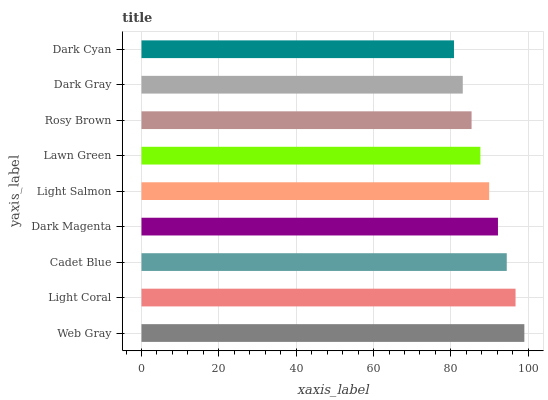Is Dark Cyan the minimum?
Answer yes or no. Yes. Is Web Gray the maximum?
Answer yes or no. Yes. Is Light Coral the minimum?
Answer yes or no. No. Is Light Coral the maximum?
Answer yes or no. No. Is Web Gray greater than Light Coral?
Answer yes or no. Yes. Is Light Coral less than Web Gray?
Answer yes or no. Yes. Is Light Coral greater than Web Gray?
Answer yes or no. No. Is Web Gray less than Light Coral?
Answer yes or no. No. Is Light Salmon the high median?
Answer yes or no. Yes. Is Light Salmon the low median?
Answer yes or no. Yes. Is Light Coral the high median?
Answer yes or no. No. Is Rosy Brown the low median?
Answer yes or no. No. 